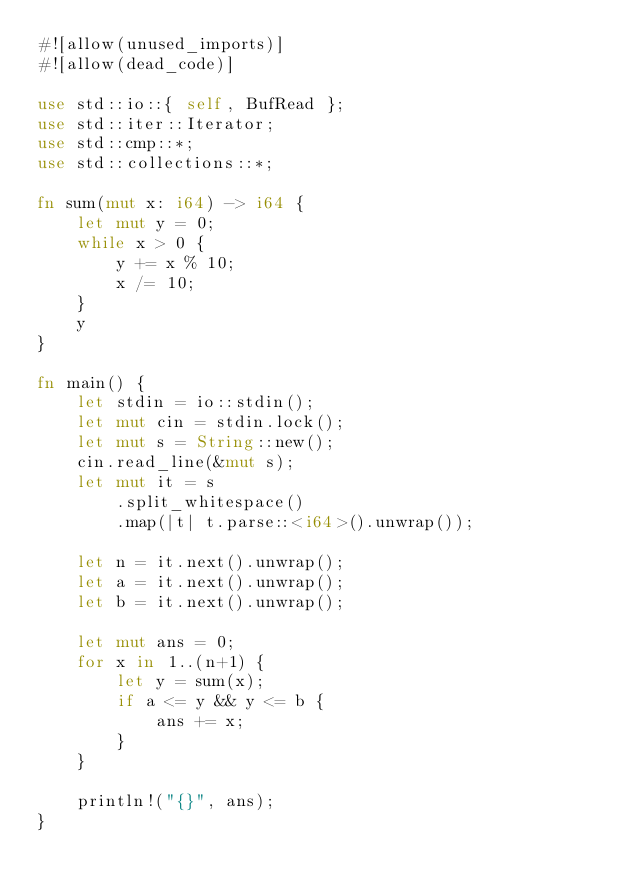<code> <loc_0><loc_0><loc_500><loc_500><_Rust_>#![allow(unused_imports)]
#![allow(dead_code)]

use std::io::{ self, BufRead };
use std::iter::Iterator;
use std::cmp::*;
use std::collections::*;

fn sum(mut x: i64) -> i64 {
    let mut y = 0;
    while x > 0 {
        y += x % 10;
        x /= 10;
    }
    y
}

fn main() {
    let stdin = io::stdin();
    let mut cin = stdin.lock();
    let mut s = String::new();
    cin.read_line(&mut s);
    let mut it = s
        .split_whitespace()
        .map(|t| t.parse::<i64>().unwrap());

    let n = it.next().unwrap();
    let a = it.next().unwrap();
    let b = it.next().unwrap();

    let mut ans = 0;
    for x in 1..(n+1) {
        let y = sum(x);
        if a <= y && y <= b {
            ans += x;
        }
    }

    println!("{}", ans);
}</code> 